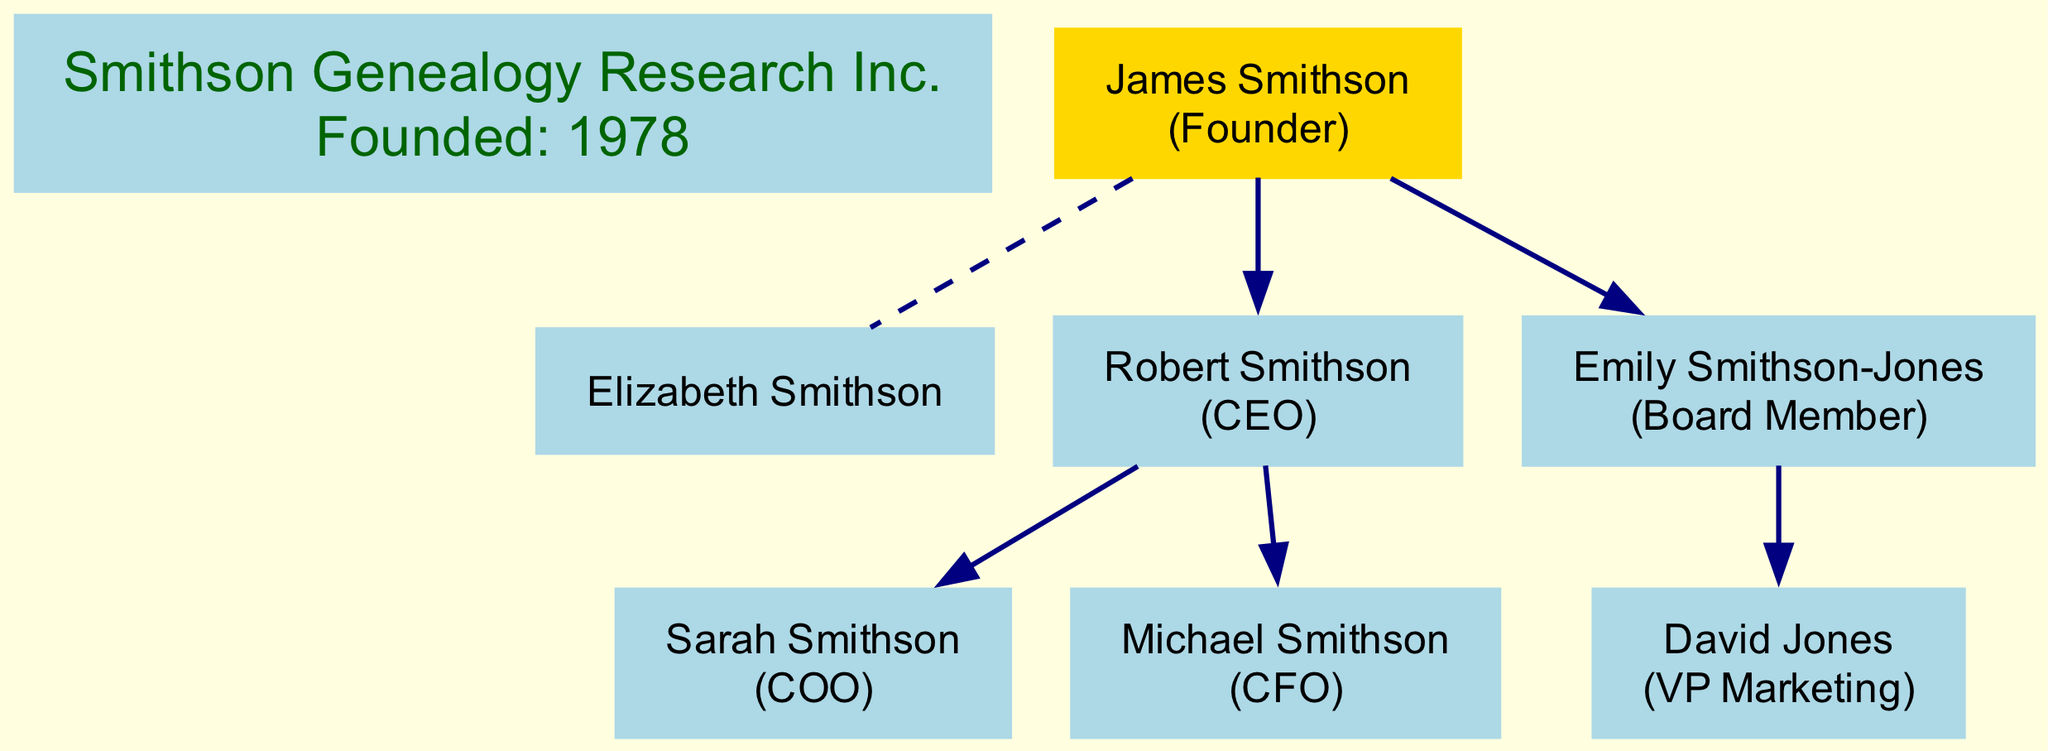What is the name of the founder? The diagram clearly identifies the founder of the company as "James Smithson". This information is located at the top of the diagram.
Answer: James Smithson Who is the spouse of James Smithson? According to the diagram, "Elizabeth Smithson" is listed as the spouse of James Smithson, shown directly below him with a dashed line connecting them.
Answer: Elizabeth Smithson How many children does James Smithson have? By examining the diagram, we see there are two children listed under James Smithson: Robert and Emily Smithson-Jones. Therefore, the total number is two.
Answer: 2 What role does Robert Smithson hold? The diagram specifies that "Robert Smithson" holds the position of CEO, which is noted next to his name in the diagram.
Answer: CEO Who is the VP Marketing? Looking at the descendants in the diagram, "David Jones" is designated as the VP Marketing, indicated under his parent, Emily Smithson-Jones.
Answer: David Jones What is the founding year of the company? The founding year is mentioned directly in the company node. In this case, it states that Smithson Genealogy Research Inc. was founded in the year 1978.
Answer: 1978 Which child of James Smithson is a Board Member? The diagram shows "Emily Smithson-Jones" listed as a Board Member, depicting her role directly next to her name in the structure.
Answer: Emily Smithson-Jones How many grandchildren does James Smithson have? The diagram reveals that Robert Smithson has two children: Sarah and Michael Smithson, and Emily Smithson-Jones has one child: David Jones. Therefore, the total is three grandchildren.
Answer: 3 What relationship does David Jones have to James Smithson? Analyzing the lineage detailed in the diagram, it can be determined that David Jones is the grandson of James Smithson, as he is the son of Emily Smithson-Jones, who is James's daughter.
Answer: Grandson 